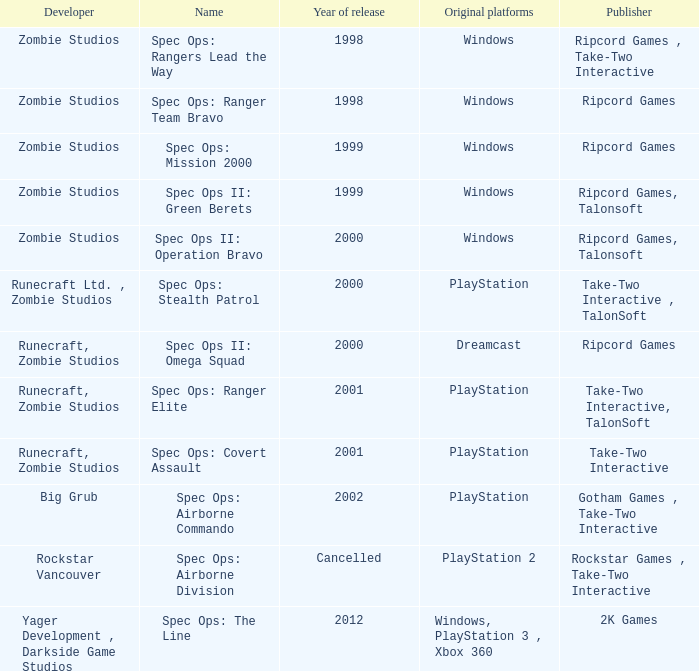Which developer has a year of cancelled releases? Rockstar Vancouver. 